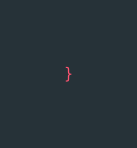Convert code to text. <code><loc_0><loc_0><loc_500><loc_500><_CSS_>}
</code> 